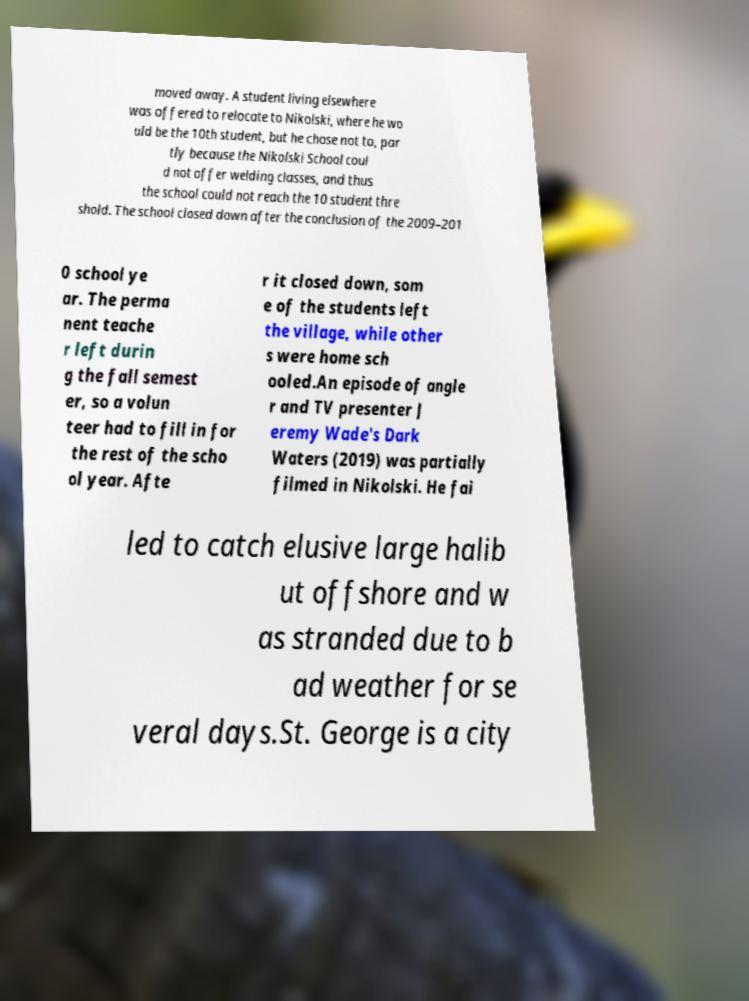Could you extract and type out the text from this image? moved away. A student living elsewhere was offered to relocate to Nikolski, where he wo uld be the 10th student, but he chose not to, par tly because the Nikolski School coul d not offer welding classes, and thus the school could not reach the 10 student thre shold. The school closed down after the conclusion of the 2009–201 0 school ye ar. The perma nent teache r left durin g the fall semest er, so a volun teer had to fill in for the rest of the scho ol year. Afte r it closed down, som e of the students left the village, while other s were home sch ooled.An episode of angle r and TV presenter J eremy Wade's Dark Waters (2019) was partially filmed in Nikolski. He fai led to catch elusive large halib ut offshore and w as stranded due to b ad weather for se veral days.St. George is a city 